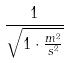Convert formula to latex. <formula><loc_0><loc_0><loc_500><loc_500>\frac { 1 } { \sqrt { 1 \cdot \frac { m ^ { 2 } } { s ^ { 2 } } } }</formula> 